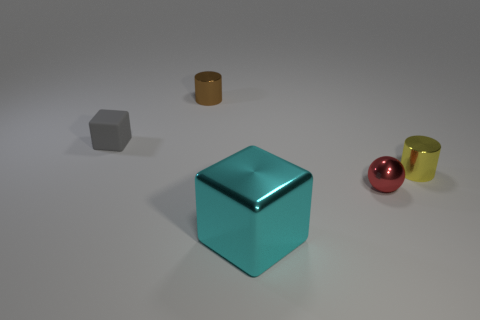Do the shiny cylinder that is right of the red metallic object and the cyan metallic block have the same size?
Your answer should be compact. No. There is a small cylinder on the right side of the big cyan metal cube; how many red things are to the right of it?
Offer a very short reply. 0. Is there anything else that is the same shape as the tiny red metallic object?
Ensure brevity in your answer.  No. Are there fewer metal cylinders than big objects?
Make the answer very short. No. What shape is the object that is on the left side of the cylinder that is to the left of the small metallic ball?
Give a very brief answer. Cube. Are there any other things that have the same size as the cyan metallic thing?
Offer a very short reply. No. There is a tiny metal thing behind the tiny metal cylinder that is in front of the gray block left of the tiny red metallic thing; what shape is it?
Provide a succinct answer. Cylinder. How many objects are blocks that are to the right of the tiny brown metallic object or metal objects that are behind the tiny yellow metal cylinder?
Keep it short and to the point. 2. There is a brown thing; is it the same size as the cylinder that is to the right of the brown metallic cylinder?
Your answer should be compact. Yes. Is the material of the small cylinder that is in front of the brown metal cylinder the same as the tiny cylinder to the left of the large object?
Offer a very short reply. Yes. 